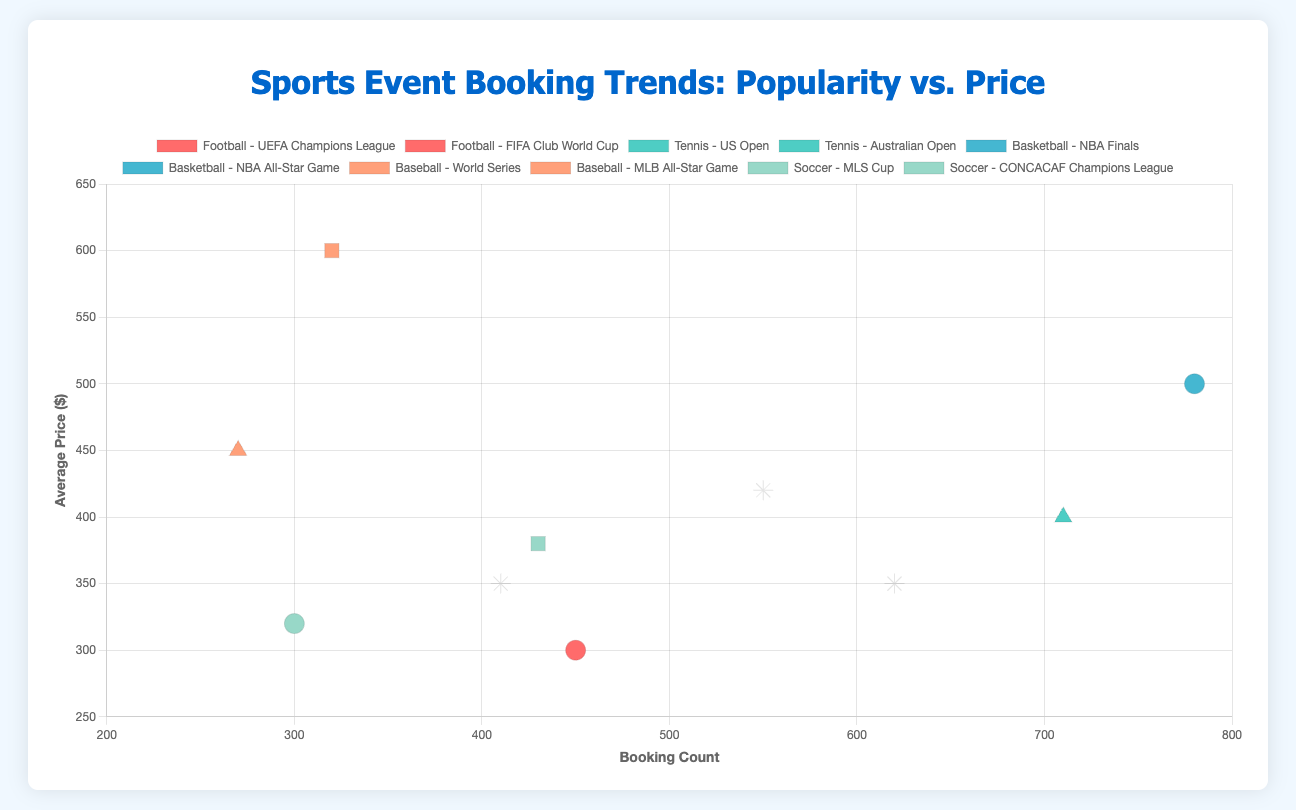Which sport event has the highest booking count? To find the sport event with the highest booking count, locate the data point farthest to the right on the x-axis, which represents the booking count. The event with the highest booking count is the "NBA Finals" for Basketball with 780 bookings.
Answer: NBA Finals What is the average price for the sports event with the lowest booking count? Identify the data point farthest to the left on the x-axis to find the lowest booking count, which corresponds to the "MLB All-Star Game" for Baseball with 270 bookings. The average price for this event is $450, as indicated on the y-axis.
Answer: $450 How do the booking counts for Spring season sports events compare to Winter season sports events? Locate the data points representing Spring events (circle shapes) and Winter events (star shapes) on the scatter plot. Spring events are "UEFA Champions League" (450 bookings), "NBA Finals" (780 bookings), and "CONCACAF Champions League" (300 bookings). Winter events are "FIFA Club World Cup" (620 bookings), "Australian Open" (550 bookings), and "NBA All-Star Game" (410 bookings). By comparing the values, Winter events have 620 + 550 + 410 = 1580 bookings, while Spring events have 450 + 780 + 300 = 1530 bookings. Winter season sports events have slightly higher booking counts overall.
Answer: Winter sports events have higher booking counts Which sport has the highest average price for its event(s)? Look for the highest y-values (average price) on the scatter plot. The highest y-value data point represents the "World Series" for Baseball with an average price of $600. Hence, Baseball has the highest average price for its event.
Answer: Baseball What is the difference in average price between the "NBA Finals" and the "US Open"? Locate the "NBA Finals" data point (Basketball) with an average price of $500 and the "US Open" data point (Tennis) with an average price of $400. Subtract the lower average price from the higher average price: $500 - $400 = $100.
Answer: $100 In which season do we find the event with the highest average price? Identify the highest y-value point, which represents the "World Series" with an average price of $600. The season for this event is Fall.
Answer: Fall Which sports event has the most equal (closest) values of booking count and average price? Compare the x (booking count) and y (average price) values for each data point to find the event where these values are the most equal. The "NBA All-Star Game" (Basketball) with booking count 410 and average price $350 has the values closest to each other, with the smallest disparity of 410 - 350 = 60.
Answer: NBA All-Star Game 